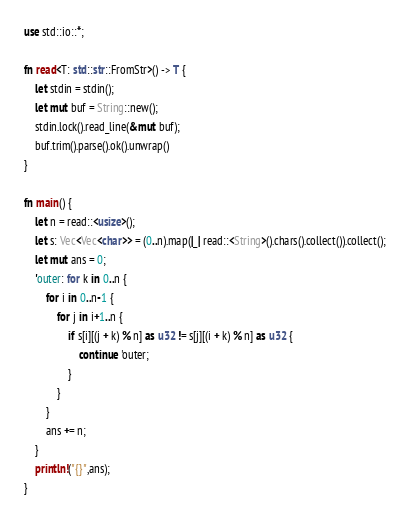Convert code to text. <code><loc_0><loc_0><loc_500><loc_500><_Rust_>use std::io::*;

fn read<T: std::str::FromStr>() -> T {
    let stdin = stdin();
    let mut buf = String::new();
	stdin.lock().read_line(&mut buf);
	buf.trim().parse().ok().unwrap()
}

fn main() {
    let n = read::<usize>();
    let s: Vec<Vec<char>> = (0..n).map(|_| read::<String>().chars().collect()).collect();
    let mut ans = 0;
    'outer: for k in 0..n {
        for i in 0..n-1 {
            for j in i+1..n {
                if s[i][(j + k) % n] as u32 != s[j][(i + k) % n] as u32 {
                    continue 'outer;
                }
            }
        }
        ans += n;
    }
    println!("{}",ans);
}
</code> 